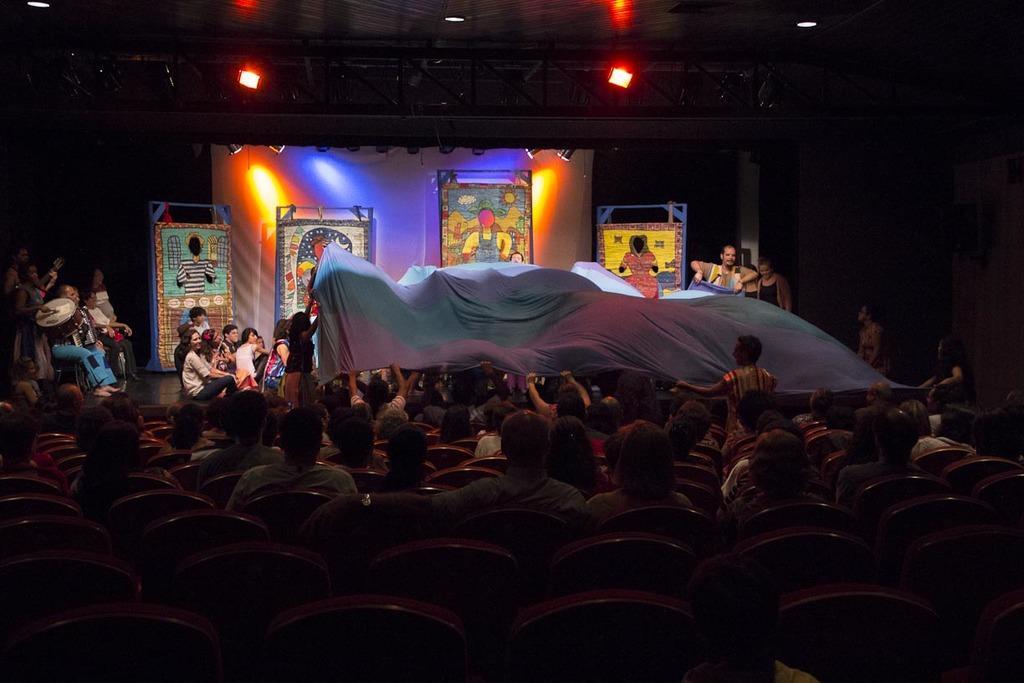How would you summarize this image in a sentence or two? In this picture there are group of people sitting on the chairs and there are group of people sitting on the stage and there are two person holding the sheet and there is a person standing and playing the drums and there is a person standing and holding the guitar. At the back there are boards. At the top there are lights. 